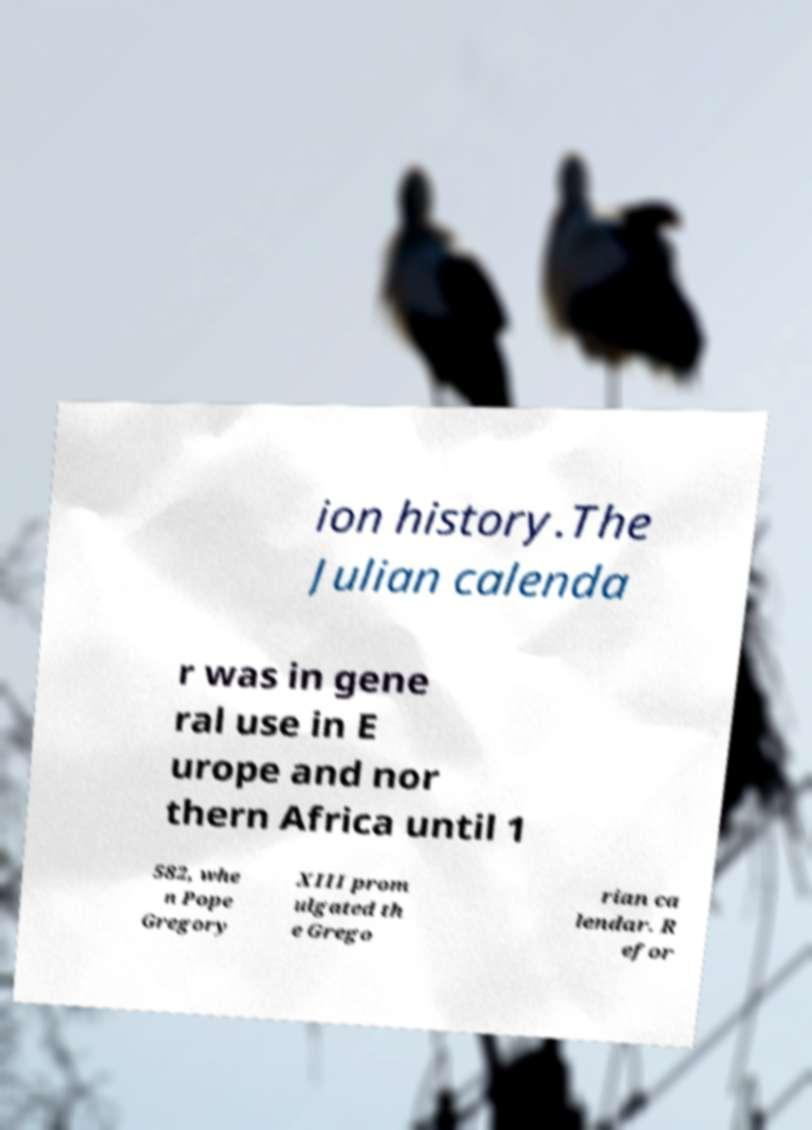Can you accurately transcribe the text from the provided image for me? ion history.The Julian calenda r was in gene ral use in E urope and nor thern Africa until 1 582, whe n Pope Gregory XIII prom ulgated th e Grego rian ca lendar. R efor 